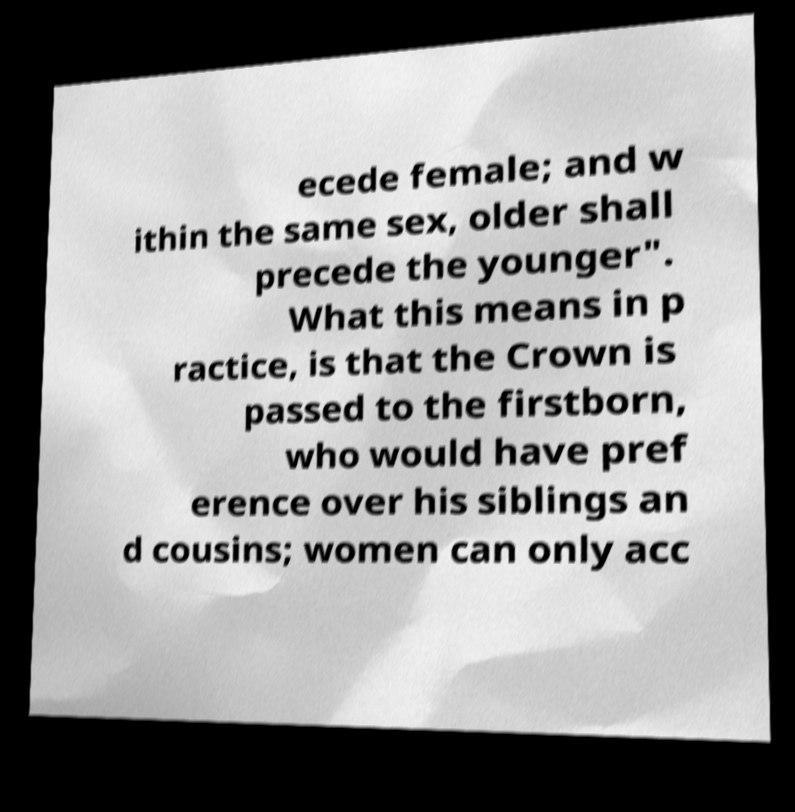For documentation purposes, I need the text within this image transcribed. Could you provide that? ecede female; and w ithin the same sex, older shall precede the younger". What this means in p ractice, is that the Crown is passed to the firstborn, who would have pref erence over his siblings an d cousins; women can only acc 